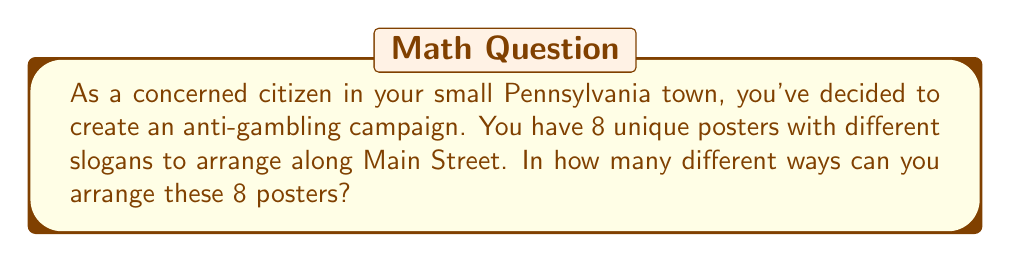Can you solve this math problem? To solve this problem, we need to use the concept of permutations. A permutation is an arrangement of objects in a specific order. In this case, we are arranging 8 unique posters, and the order matters.

The formula for permutations of n distinct objects is:

$$P(n) = n!$$

Where $n!$ (n factorial) is the product of all positive integers less than or equal to n.

In our case, $n = 8$ (the number of unique posters).

So, we calculate:

$$\begin{align*}
P(8) &= 8! \\
&= 8 \times 7 \times 6 \times 5 \times 4 \times 3 \times 2 \times 1 \\
&= 40,320
\end{align*}$$

This means there are 40,320 different ways to arrange the 8 unique anti-gambling campaign posters along Main Street.

The large number of arrangements demonstrates the flexibility you have in designing your campaign layout, allowing you to frequently change the order to keep the message fresh and noticeable to passersby.
Answer: 40,320 unique arrangements 